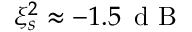Convert formula to latex. <formula><loc_0><loc_0><loc_500><loc_500>\xi _ { s } ^ { 2 } \approx - 1 . 5 \, d B</formula> 